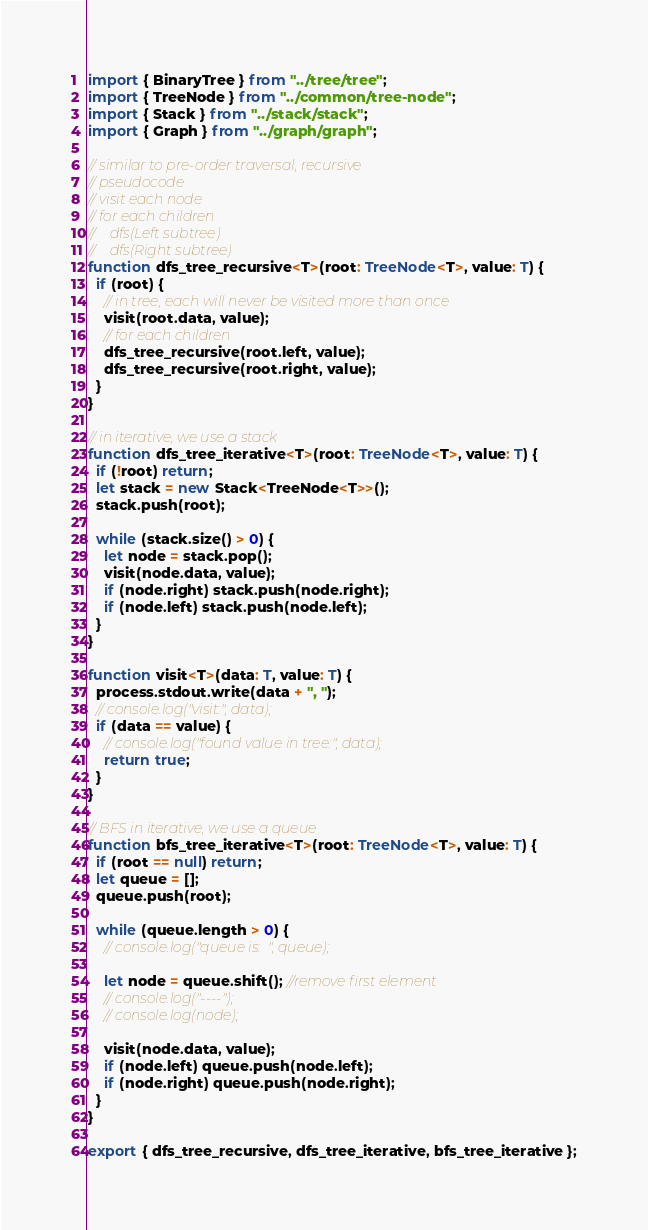Convert code to text. <code><loc_0><loc_0><loc_500><loc_500><_TypeScript_>import { BinaryTree } from "../tree/tree";
import { TreeNode } from "../common/tree-node";
import { Stack } from "../stack/stack";
import { Graph } from "../graph/graph";

// similar to pre-order traversal, recursive
// pseudocode
// visit each node
// for each children
//    dfs(Left subtree)
//    dfs(Right subtree)
function dfs_tree_recursive<T>(root: TreeNode<T>, value: T) {
  if (root) {
    // in tree, each will never be visited more than once
    visit(root.data, value);
    // for each children
    dfs_tree_recursive(root.left, value);
    dfs_tree_recursive(root.right, value);
  }
}

// in iterative, we use a stack
function dfs_tree_iterative<T>(root: TreeNode<T>, value: T) {
  if (!root) return;
  let stack = new Stack<TreeNode<T>>();
  stack.push(root);

  while (stack.size() > 0) {
    let node = stack.pop();
    visit(node.data, value);
    if (node.right) stack.push(node.right);
    if (node.left) stack.push(node.left);
  }
}

function visit<T>(data: T, value: T) {
  process.stdout.write(data + ", ");
  // console.log("visit:", data);
  if (data == value) {
    // console.log("found value in tree:", data);
    return true;
  }
}

// BFS in iterative, we use a queue
function bfs_tree_iterative<T>(root: TreeNode<T>, value: T) {
  if (root == null) return;
  let queue = [];
  queue.push(root);

  while (queue.length > 0) {
    // console.log("queue is:  ", queue);

    let node = queue.shift(); //remove first element
    // console.log("----");
    // console.log(node);

    visit(node.data, value);
    if (node.left) queue.push(node.left);
    if (node.right) queue.push(node.right);
  }
}

export { dfs_tree_recursive, dfs_tree_iterative, bfs_tree_iterative };
</code> 